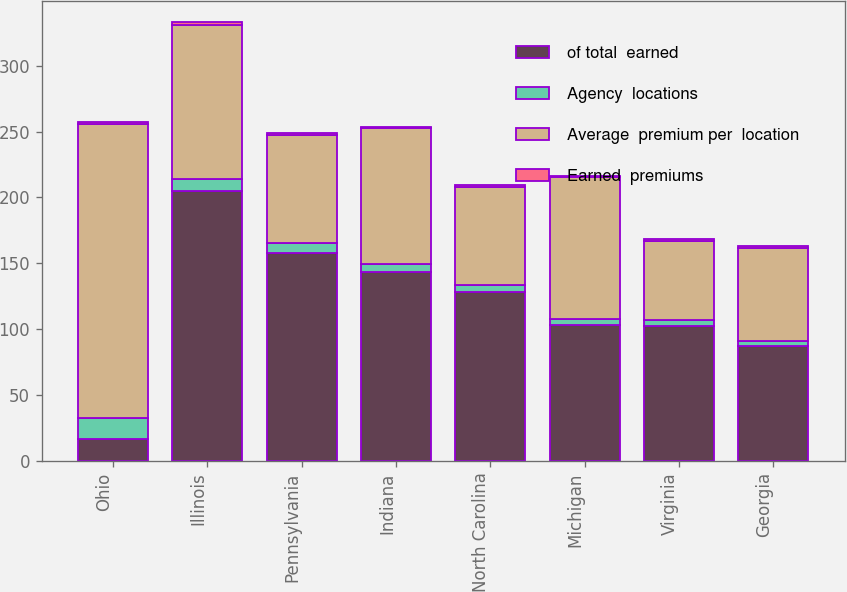Convert chart. <chart><loc_0><loc_0><loc_500><loc_500><stacked_bar_chart><ecel><fcel>Ohio<fcel>Illinois<fcel>Pennsylvania<fcel>Indiana<fcel>North Carolina<fcel>Michigan<fcel>Virginia<fcel>Georgia<nl><fcel>of total  earned<fcel>16.3<fcel>205<fcel>158<fcel>143<fcel>128<fcel>103<fcel>102<fcel>87<nl><fcel>Agency  locations<fcel>16.3<fcel>9.2<fcel>7.1<fcel>6.4<fcel>5.8<fcel>4.6<fcel>4.6<fcel>3.9<nl><fcel>Average  premium per  location<fcel>223<fcel>117<fcel>82<fcel>103<fcel>74<fcel>108<fcel>60<fcel>71<nl><fcel>Earned  premiums<fcel>1.6<fcel>1.8<fcel>1.9<fcel>1.4<fcel>1.7<fcel>1<fcel>1.7<fcel>1.2<nl></chart> 